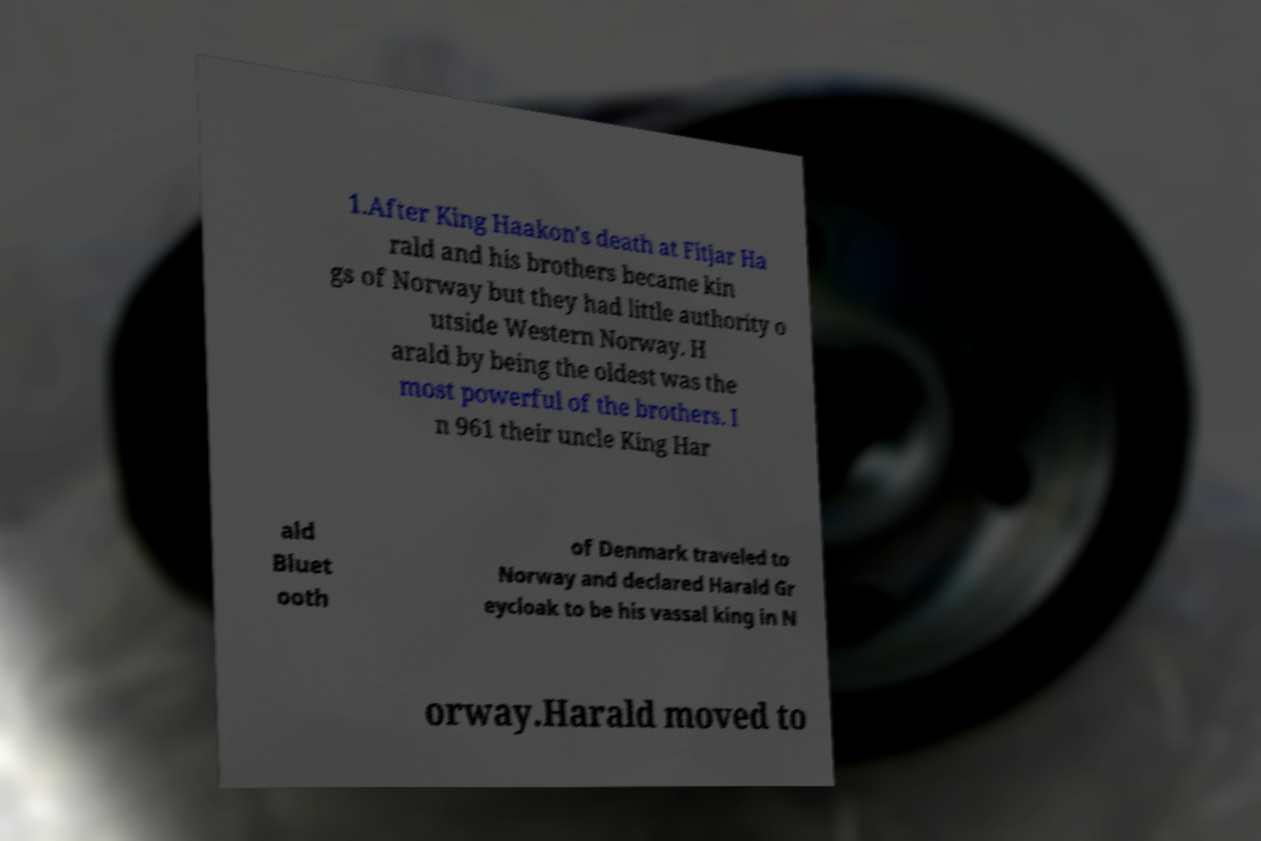What messages or text are displayed in this image? I need them in a readable, typed format. 1.After King Haakon's death at Fitjar Ha rald and his brothers became kin gs of Norway but they had little authority o utside Western Norway. H arald by being the oldest was the most powerful of the brothers. I n 961 their uncle King Har ald Bluet ooth of Denmark traveled to Norway and declared Harald Gr eycloak to be his vassal king in N orway.Harald moved to 